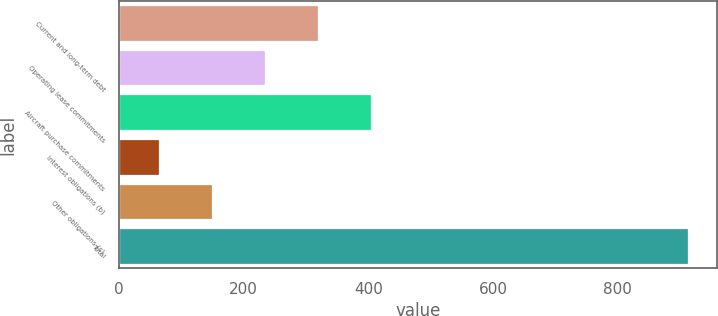Convert chart to OTSL. <chart><loc_0><loc_0><loc_500><loc_500><bar_chart><fcel>Current and long-term debt<fcel>Operating lease commitments<fcel>Aircraft purchase commitments<fcel>Interest obligations (b)<fcel>Other obligations (c)<fcel>Total<nl><fcel>318.78<fcel>233.82<fcel>403.74<fcel>63.9<fcel>148.86<fcel>913.5<nl></chart> 